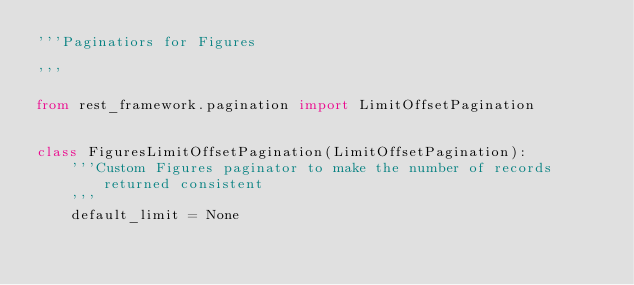Convert code to text. <code><loc_0><loc_0><loc_500><loc_500><_Python_>'''Paginatiors for Figures

'''

from rest_framework.pagination import LimitOffsetPagination


class FiguresLimitOffsetPagination(LimitOffsetPagination):
    '''Custom Figures paginator to make the number of records returned consistent
    '''
    default_limit = None
</code> 